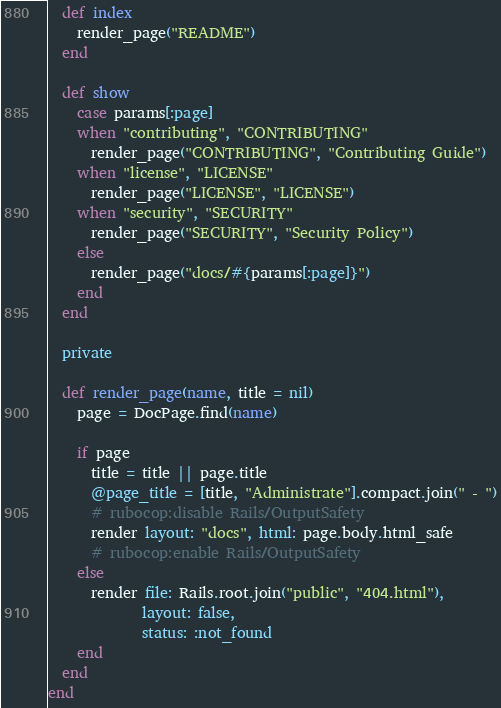<code> <loc_0><loc_0><loc_500><loc_500><_Ruby_>  def index
    render_page("README")
  end

  def show
    case params[:page]
    when "contributing", "CONTRIBUTING"
      render_page("CONTRIBUTING", "Contributing Guide")
    when "license", "LICENSE"
      render_page("LICENSE", "LICENSE")
    when "security", "SECURITY"
      render_page("SECURITY", "Security Policy")
    else
      render_page("docs/#{params[:page]}")
    end
  end

  private

  def render_page(name, title = nil)
    page = DocPage.find(name)

    if page
      title = title || page.title
      @page_title = [title, "Administrate"].compact.join(" - ")
      # rubocop:disable Rails/OutputSafety
      render layout: "docs", html: page.body.html_safe
      # rubocop:enable Rails/OutputSafety
    else
      render file: Rails.root.join("public", "404.html"),
             layout: false,
             status: :not_found
    end
  end
end
</code> 